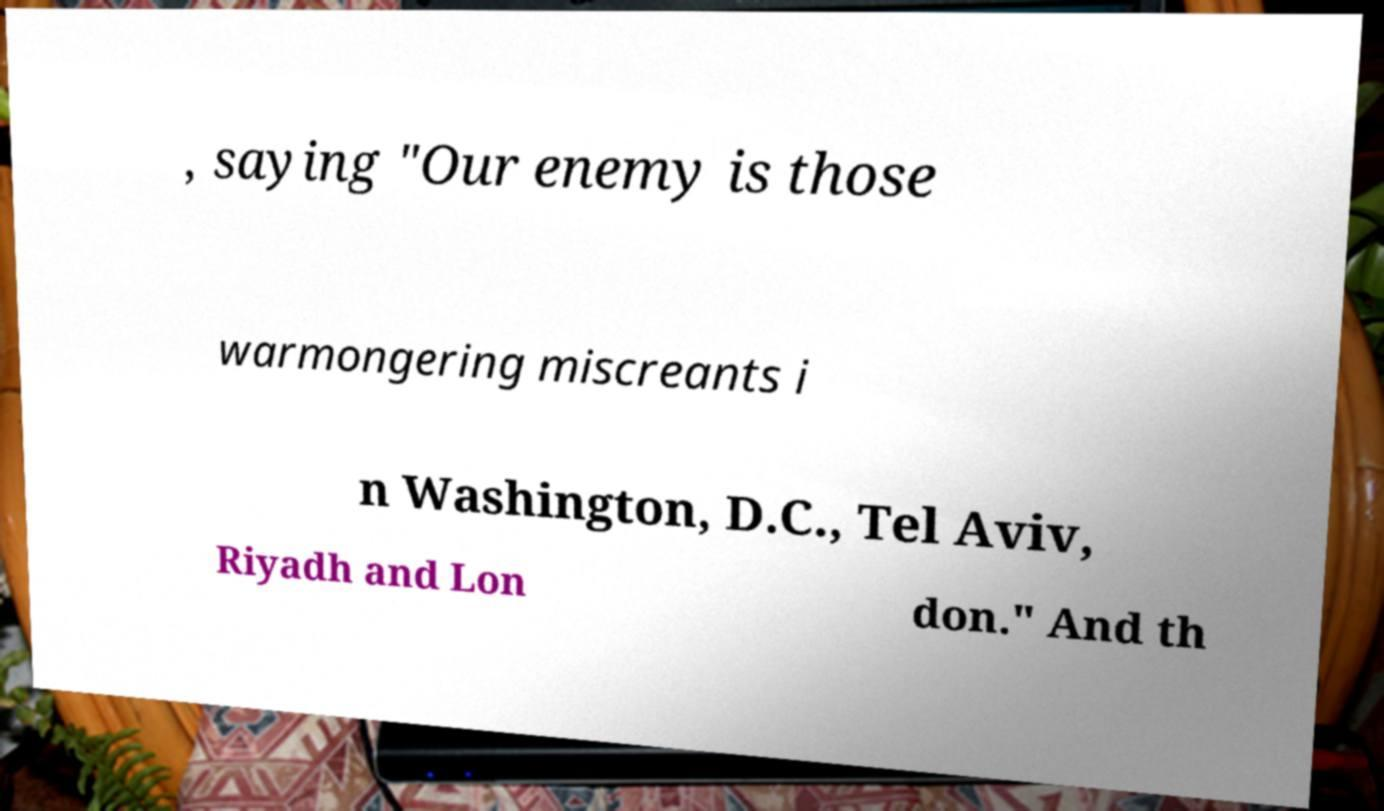For documentation purposes, I need the text within this image transcribed. Could you provide that? , saying "Our enemy is those warmongering miscreants i n Washington, D.C., Tel Aviv, Riyadh and Lon don." And th 